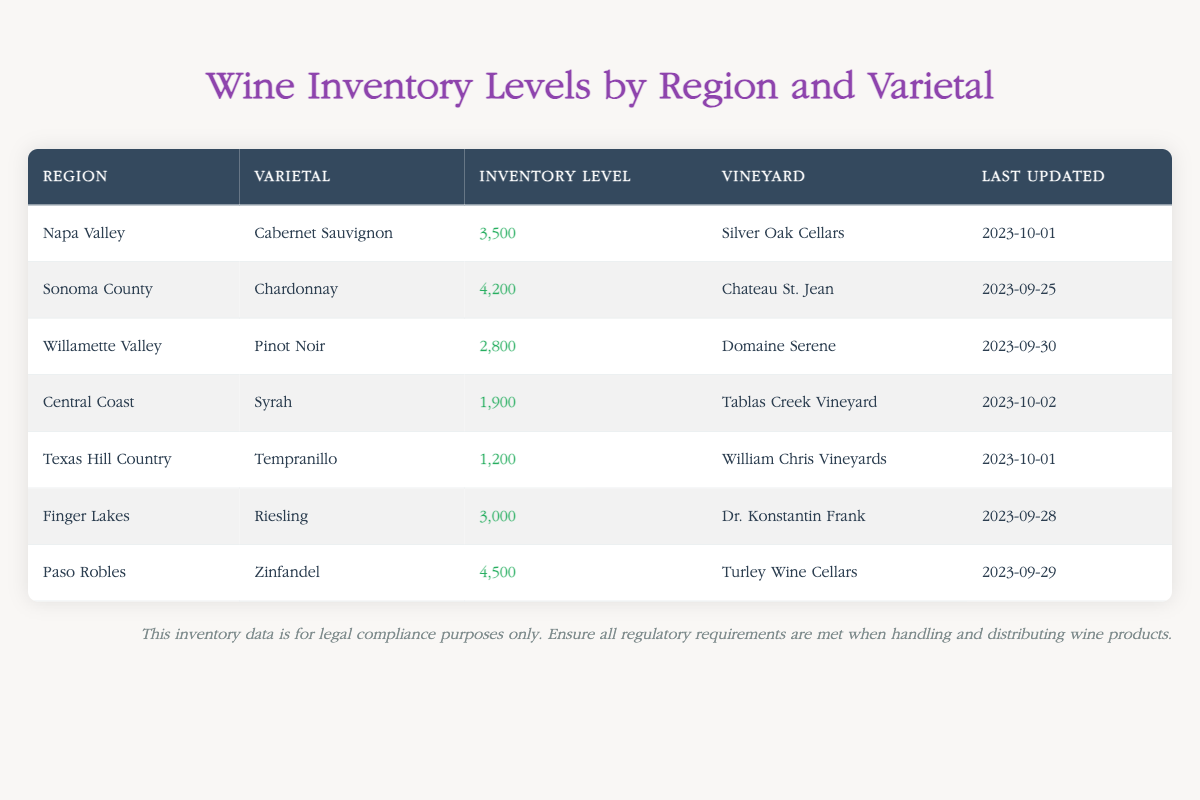What is the inventory level of Cabernet Sauvignon in Napa Valley? The table indicates that the inventory level for Cabernet Sauvignon in Napa Valley is recorded as 3500.
Answer: 3500 How many vineyards in the table have an inventory level greater than 3000? By examining the inventory levels: Napa Valley (3500), Sonoma County (4200), Finger Lakes (3000), and Paso Robles (4500) are above 3000. There are 4 vineyards in total that meet this criterion.
Answer: 4 Is there a wine varietal from Texas Hill Country in the inventory? Yes, according to the table, there is Tempranillo from Texas Hill Country listed in the inventory.
Answer: Yes What is the difference between the highest and lowest inventory levels? The highest inventory level is 4500 (Paso Robles, Zinfandel) and the lowest is 1200 (Texas Hill Country, Tempranillo). The difference is 4500 - 1200 = 3300.
Answer: 3300 List all regions that have an inventory level of 3000 or more. The regions with inventory levels of 3000 or more are Napa Valley (3500), Sonoma County (4200), Finger Lakes (3000), and Paso Robles (4500). After reviewing the table, there are 4 such regions listed.
Answer: 4 regions What varietal has the lowest inventory level, and how much is it? By reviewing the inventory levels, Tempranillo from Texas Hill Country has the lowest inventory level at 1200.
Answer: Tempranillo, 1200 Are there any varietals from locations updated in October 2023? Yes, both Cabernet Sauvignon (Napa Valley) and Syrah (Central Coast) have been updated in October 2023, as indicated by their last updated dates in the table.
Answer: Yes What is the total inventory level of Chardonnay and Sauvignon from the inventory? The inventory level for Chardonnay from Sonoma County is 4200, and it appears there is no Sauvignon varietal listed. Thus, total inventory is only 4200 (from Chardonnay).
Answer: 4200 How many regions have an inventory level of less than 2000? Upon reviewing the table, both Central Coast (1900) and Texas Hill Country (1200) have inventory levels below 2000, resulting in a total of 2 regions.
Answer: 2 